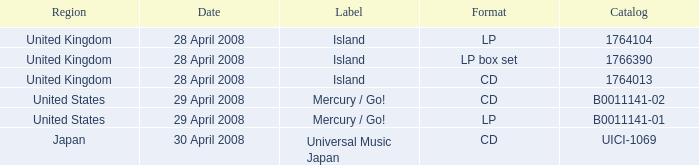What is the identifier of the b0011141-01 catalog? Mercury / Go!. 